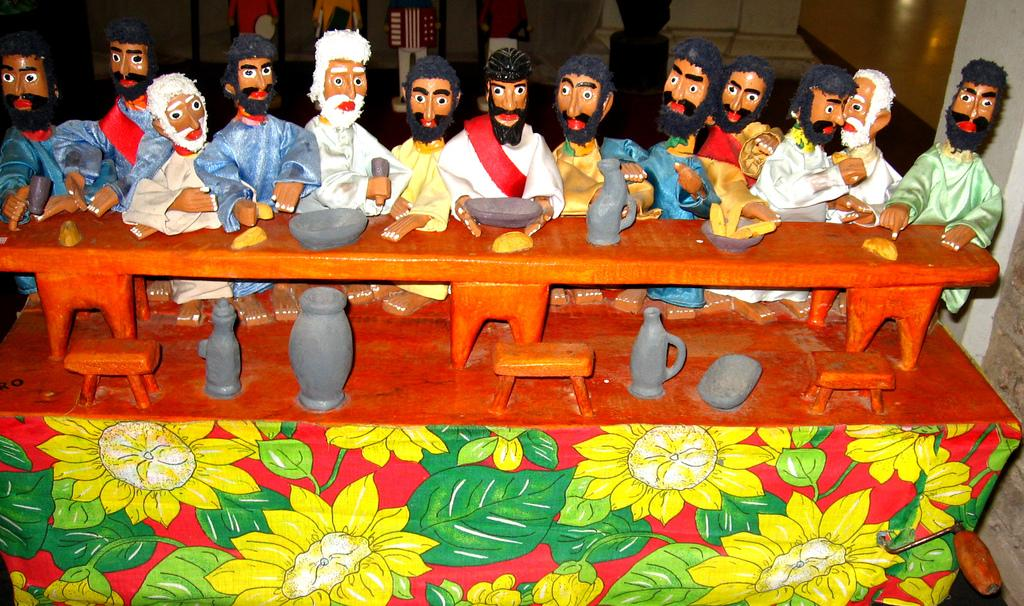What type of furniture is in the image? There is a miniature bench in the image. What color is the bench? The bench is brown in color. What are the people in the image doing? There are persons sitting around the bench. What can be found on the bench? There are bowls and other objects on the bench. What type of mist is covering the bench in the image? There is no mist present in the image; the bench is clearly visible. 